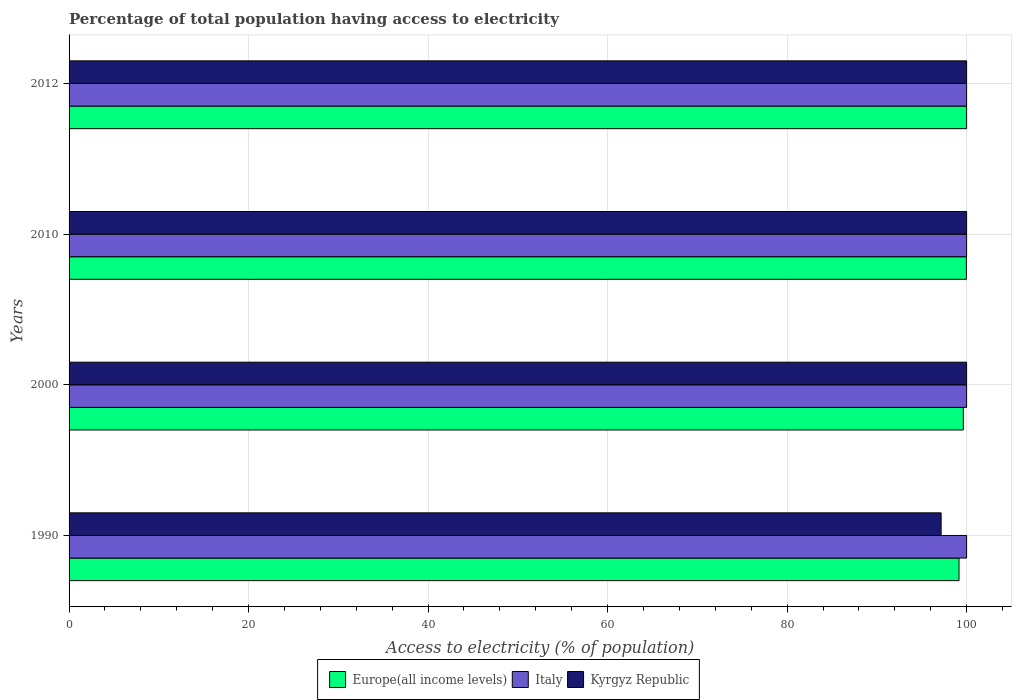Are the number of bars per tick equal to the number of legend labels?
Your answer should be very brief. Yes. Are the number of bars on each tick of the Y-axis equal?
Your answer should be compact. Yes. How many bars are there on the 3rd tick from the top?
Ensure brevity in your answer.  3. What is the label of the 2nd group of bars from the top?
Make the answer very short. 2010. What is the percentage of population that have access to electricity in Europe(all income levels) in 2010?
Keep it short and to the point. 99.97. Across all years, what is the minimum percentage of population that have access to electricity in Kyrgyz Republic?
Your answer should be very brief. 97.16. In which year was the percentage of population that have access to electricity in Kyrgyz Republic maximum?
Your answer should be compact. 2000. In which year was the percentage of population that have access to electricity in Kyrgyz Republic minimum?
Make the answer very short. 1990. What is the total percentage of population that have access to electricity in Europe(all income levels) in the graph?
Offer a terse response. 398.76. What is the difference between the percentage of population that have access to electricity in Kyrgyz Republic in 2000 and that in 2012?
Your response must be concise. 0. What is the difference between the percentage of population that have access to electricity in Italy in 2010 and the percentage of population that have access to electricity in Kyrgyz Republic in 2000?
Provide a succinct answer. 0. What is the average percentage of population that have access to electricity in Italy per year?
Your answer should be compact. 100. In the year 2012, what is the difference between the percentage of population that have access to electricity in Italy and percentage of population that have access to electricity in Europe(all income levels)?
Provide a succinct answer. 0. In how many years, is the percentage of population that have access to electricity in Kyrgyz Republic greater than 88 %?
Provide a short and direct response. 4. What is the ratio of the percentage of population that have access to electricity in Europe(all income levels) in 1990 to that in 2012?
Ensure brevity in your answer.  0.99. Is the difference between the percentage of population that have access to electricity in Italy in 2010 and 2012 greater than the difference between the percentage of population that have access to electricity in Europe(all income levels) in 2010 and 2012?
Your answer should be compact. Yes. In how many years, is the percentage of population that have access to electricity in Europe(all income levels) greater than the average percentage of population that have access to electricity in Europe(all income levels) taken over all years?
Provide a short and direct response. 2. Is the sum of the percentage of population that have access to electricity in Kyrgyz Republic in 2010 and 2012 greater than the maximum percentage of population that have access to electricity in Italy across all years?
Offer a very short reply. Yes. What does the 3rd bar from the top in 1990 represents?
Provide a succinct answer. Europe(all income levels). What does the 1st bar from the bottom in 1990 represents?
Make the answer very short. Europe(all income levels). How many bars are there?
Your answer should be compact. 12. How many years are there in the graph?
Make the answer very short. 4. Does the graph contain any zero values?
Offer a terse response. No. Does the graph contain grids?
Provide a short and direct response. Yes. How many legend labels are there?
Provide a succinct answer. 3. How are the legend labels stacked?
Ensure brevity in your answer.  Horizontal. What is the title of the graph?
Ensure brevity in your answer.  Percentage of total population having access to electricity. What is the label or title of the X-axis?
Provide a short and direct response. Access to electricity (% of population). What is the Access to electricity (% of population) in Europe(all income levels) in 1990?
Keep it short and to the point. 99.15. What is the Access to electricity (% of population) in Italy in 1990?
Provide a short and direct response. 100. What is the Access to electricity (% of population) of Kyrgyz Republic in 1990?
Make the answer very short. 97.16. What is the Access to electricity (% of population) in Europe(all income levels) in 2000?
Your answer should be very brief. 99.63. What is the Access to electricity (% of population) of Italy in 2000?
Keep it short and to the point. 100. What is the Access to electricity (% of population) of Kyrgyz Republic in 2000?
Your response must be concise. 100. What is the Access to electricity (% of population) in Europe(all income levels) in 2010?
Offer a terse response. 99.97. What is the Access to electricity (% of population) of Italy in 2010?
Offer a terse response. 100. What is the Access to electricity (% of population) in Kyrgyz Republic in 2010?
Provide a succinct answer. 100. What is the Access to electricity (% of population) of Europe(all income levels) in 2012?
Make the answer very short. 100. What is the Access to electricity (% of population) in Italy in 2012?
Offer a terse response. 100. What is the Access to electricity (% of population) of Kyrgyz Republic in 2012?
Keep it short and to the point. 100. Across all years, what is the maximum Access to electricity (% of population) of Europe(all income levels)?
Provide a short and direct response. 100. Across all years, what is the minimum Access to electricity (% of population) of Europe(all income levels)?
Make the answer very short. 99.15. Across all years, what is the minimum Access to electricity (% of population) of Italy?
Your answer should be compact. 100. Across all years, what is the minimum Access to electricity (% of population) of Kyrgyz Republic?
Keep it short and to the point. 97.16. What is the total Access to electricity (% of population) of Europe(all income levels) in the graph?
Provide a succinct answer. 398.76. What is the total Access to electricity (% of population) in Kyrgyz Republic in the graph?
Give a very brief answer. 397.16. What is the difference between the Access to electricity (% of population) of Europe(all income levels) in 1990 and that in 2000?
Ensure brevity in your answer.  -0.48. What is the difference between the Access to electricity (% of population) of Kyrgyz Republic in 1990 and that in 2000?
Keep it short and to the point. -2.84. What is the difference between the Access to electricity (% of population) in Europe(all income levels) in 1990 and that in 2010?
Your answer should be compact. -0.82. What is the difference between the Access to electricity (% of population) in Italy in 1990 and that in 2010?
Your answer should be very brief. 0. What is the difference between the Access to electricity (% of population) in Kyrgyz Republic in 1990 and that in 2010?
Provide a short and direct response. -2.84. What is the difference between the Access to electricity (% of population) in Europe(all income levels) in 1990 and that in 2012?
Provide a succinct answer. -0.85. What is the difference between the Access to electricity (% of population) in Italy in 1990 and that in 2012?
Provide a succinct answer. 0. What is the difference between the Access to electricity (% of population) of Kyrgyz Republic in 1990 and that in 2012?
Give a very brief answer. -2.84. What is the difference between the Access to electricity (% of population) of Europe(all income levels) in 2000 and that in 2010?
Provide a short and direct response. -0.34. What is the difference between the Access to electricity (% of population) in Italy in 2000 and that in 2010?
Your answer should be very brief. 0. What is the difference between the Access to electricity (% of population) of Europe(all income levels) in 2000 and that in 2012?
Keep it short and to the point. -0.37. What is the difference between the Access to electricity (% of population) of Kyrgyz Republic in 2000 and that in 2012?
Give a very brief answer. 0. What is the difference between the Access to electricity (% of population) of Europe(all income levels) in 2010 and that in 2012?
Ensure brevity in your answer.  -0.03. What is the difference between the Access to electricity (% of population) in Kyrgyz Republic in 2010 and that in 2012?
Give a very brief answer. 0. What is the difference between the Access to electricity (% of population) of Europe(all income levels) in 1990 and the Access to electricity (% of population) of Italy in 2000?
Give a very brief answer. -0.85. What is the difference between the Access to electricity (% of population) of Europe(all income levels) in 1990 and the Access to electricity (% of population) of Kyrgyz Republic in 2000?
Your answer should be compact. -0.85. What is the difference between the Access to electricity (% of population) of Europe(all income levels) in 1990 and the Access to electricity (% of population) of Italy in 2010?
Provide a succinct answer. -0.85. What is the difference between the Access to electricity (% of population) of Europe(all income levels) in 1990 and the Access to electricity (% of population) of Kyrgyz Republic in 2010?
Give a very brief answer. -0.85. What is the difference between the Access to electricity (% of population) in Europe(all income levels) in 1990 and the Access to electricity (% of population) in Italy in 2012?
Make the answer very short. -0.85. What is the difference between the Access to electricity (% of population) in Europe(all income levels) in 1990 and the Access to electricity (% of population) in Kyrgyz Republic in 2012?
Make the answer very short. -0.85. What is the difference between the Access to electricity (% of population) in Europe(all income levels) in 2000 and the Access to electricity (% of population) in Italy in 2010?
Provide a succinct answer. -0.37. What is the difference between the Access to electricity (% of population) of Europe(all income levels) in 2000 and the Access to electricity (% of population) of Kyrgyz Republic in 2010?
Provide a succinct answer. -0.37. What is the difference between the Access to electricity (% of population) of Italy in 2000 and the Access to electricity (% of population) of Kyrgyz Republic in 2010?
Offer a very short reply. 0. What is the difference between the Access to electricity (% of population) of Europe(all income levels) in 2000 and the Access to electricity (% of population) of Italy in 2012?
Provide a short and direct response. -0.37. What is the difference between the Access to electricity (% of population) of Europe(all income levels) in 2000 and the Access to electricity (% of population) of Kyrgyz Republic in 2012?
Offer a terse response. -0.37. What is the difference between the Access to electricity (% of population) of Italy in 2000 and the Access to electricity (% of population) of Kyrgyz Republic in 2012?
Your answer should be compact. 0. What is the difference between the Access to electricity (% of population) in Europe(all income levels) in 2010 and the Access to electricity (% of population) in Italy in 2012?
Offer a very short reply. -0.03. What is the difference between the Access to electricity (% of population) of Europe(all income levels) in 2010 and the Access to electricity (% of population) of Kyrgyz Republic in 2012?
Your answer should be very brief. -0.03. What is the average Access to electricity (% of population) in Europe(all income levels) per year?
Keep it short and to the point. 99.69. What is the average Access to electricity (% of population) of Kyrgyz Republic per year?
Keep it short and to the point. 99.29. In the year 1990, what is the difference between the Access to electricity (% of population) in Europe(all income levels) and Access to electricity (% of population) in Italy?
Keep it short and to the point. -0.85. In the year 1990, what is the difference between the Access to electricity (% of population) in Europe(all income levels) and Access to electricity (% of population) in Kyrgyz Republic?
Ensure brevity in your answer.  1.99. In the year 1990, what is the difference between the Access to electricity (% of population) of Italy and Access to electricity (% of population) of Kyrgyz Republic?
Give a very brief answer. 2.84. In the year 2000, what is the difference between the Access to electricity (% of population) of Europe(all income levels) and Access to electricity (% of population) of Italy?
Give a very brief answer. -0.37. In the year 2000, what is the difference between the Access to electricity (% of population) in Europe(all income levels) and Access to electricity (% of population) in Kyrgyz Republic?
Your response must be concise. -0.37. In the year 2010, what is the difference between the Access to electricity (% of population) in Europe(all income levels) and Access to electricity (% of population) in Italy?
Your answer should be compact. -0.03. In the year 2010, what is the difference between the Access to electricity (% of population) in Europe(all income levels) and Access to electricity (% of population) in Kyrgyz Republic?
Provide a short and direct response. -0.03. What is the ratio of the Access to electricity (% of population) of Europe(all income levels) in 1990 to that in 2000?
Provide a succinct answer. 1. What is the ratio of the Access to electricity (% of population) of Kyrgyz Republic in 1990 to that in 2000?
Offer a very short reply. 0.97. What is the ratio of the Access to electricity (% of population) of Italy in 1990 to that in 2010?
Your answer should be compact. 1. What is the ratio of the Access to electricity (% of population) in Kyrgyz Republic in 1990 to that in 2010?
Keep it short and to the point. 0.97. What is the ratio of the Access to electricity (% of population) of Italy in 1990 to that in 2012?
Your answer should be very brief. 1. What is the ratio of the Access to electricity (% of population) in Kyrgyz Republic in 1990 to that in 2012?
Ensure brevity in your answer.  0.97. What is the ratio of the Access to electricity (% of population) of Italy in 2000 to that in 2010?
Offer a terse response. 1. What is the ratio of the Access to electricity (% of population) of Europe(all income levels) in 2000 to that in 2012?
Provide a short and direct response. 1. What is the ratio of the Access to electricity (% of population) of Kyrgyz Republic in 2000 to that in 2012?
Give a very brief answer. 1. What is the ratio of the Access to electricity (% of population) of Italy in 2010 to that in 2012?
Your answer should be very brief. 1. What is the ratio of the Access to electricity (% of population) of Kyrgyz Republic in 2010 to that in 2012?
Your answer should be very brief. 1. What is the difference between the highest and the second highest Access to electricity (% of population) in Europe(all income levels)?
Give a very brief answer. 0.03. What is the difference between the highest and the second highest Access to electricity (% of population) in Italy?
Make the answer very short. 0. What is the difference between the highest and the lowest Access to electricity (% of population) in Europe(all income levels)?
Ensure brevity in your answer.  0.85. What is the difference between the highest and the lowest Access to electricity (% of population) of Italy?
Give a very brief answer. 0. What is the difference between the highest and the lowest Access to electricity (% of population) in Kyrgyz Republic?
Ensure brevity in your answer.  2.84. 